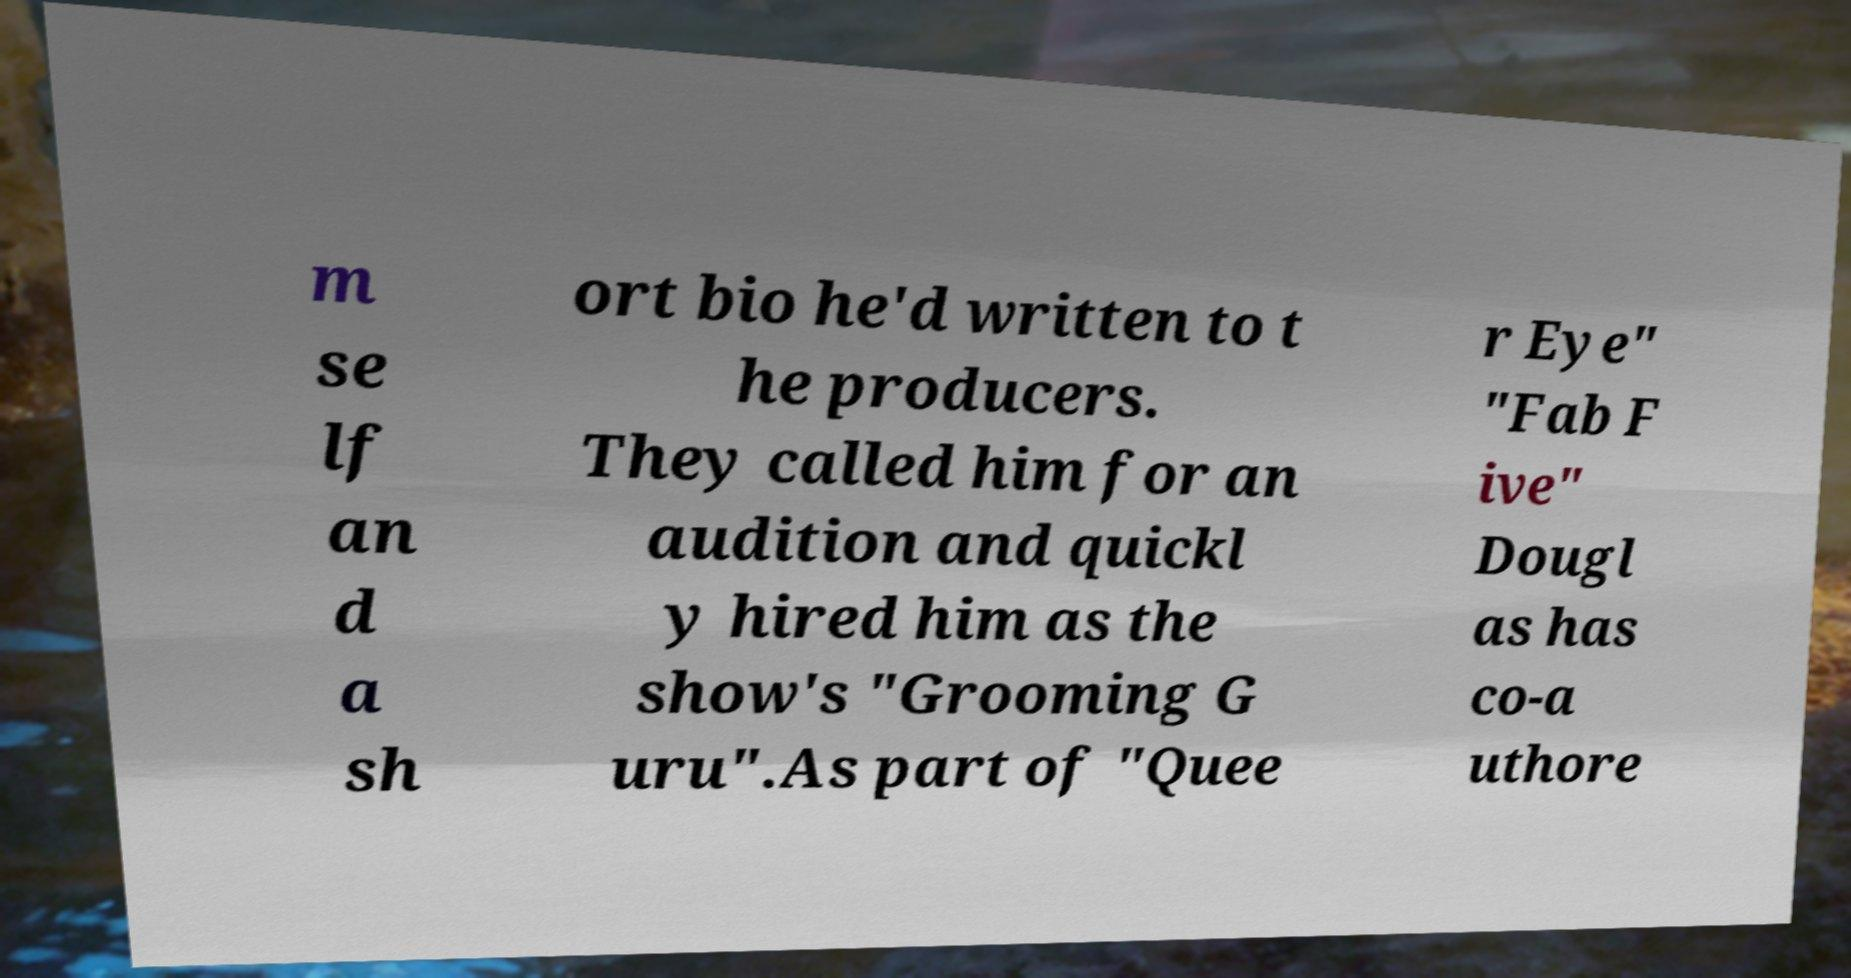There's text embedded in this image that I need extracted. Can you transcribe it verbatim? m se lf an d a sh ort bio he'd written to t he producers. They called him for an audition and quickl y hired him as the show's "Grooming G uru".As part of "Quee r Eye" "Fab F ive" Dougl as has co-a uthore 